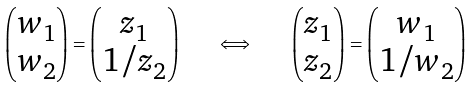<formula> <loc_0><loc_0><loc_500><loc_500>\begin{pmatrix} w _ { 1 } \\ w _ { 2 } \end{pmatrix} = \begin{pmatrix} z _ { 1 } \\ 1 / z _ { 2 } \end{pmatrix} \quad \iff \quad \begin{pmatrix} z _ { 1 } \\ z _ { 2 } \end{pmatrix} = \begin{pmatrix} w _ { 1 } \\ 1 / w _ { 2 } \end{pmatrix}</formula> 